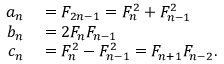<formula> <loc_0><loc_0><loc_500><loc_500>\begin{array} { r l } { a _ { n } } & = F _ { 2 n - 1 } = F _ { n } ^ { 2 } + F _ { n - 1 } ^ { 2 } } \\ { b _ { n } } & = 2 F _ { n } F _ { n - 1 } } \\ { c _ { n } } & = F _ { n } ^ { 2 } - F _ { n - 1 } ^ { 2 } = F _ { n + 1 } F _ { n - 2 } . } \end{array}</formula> 